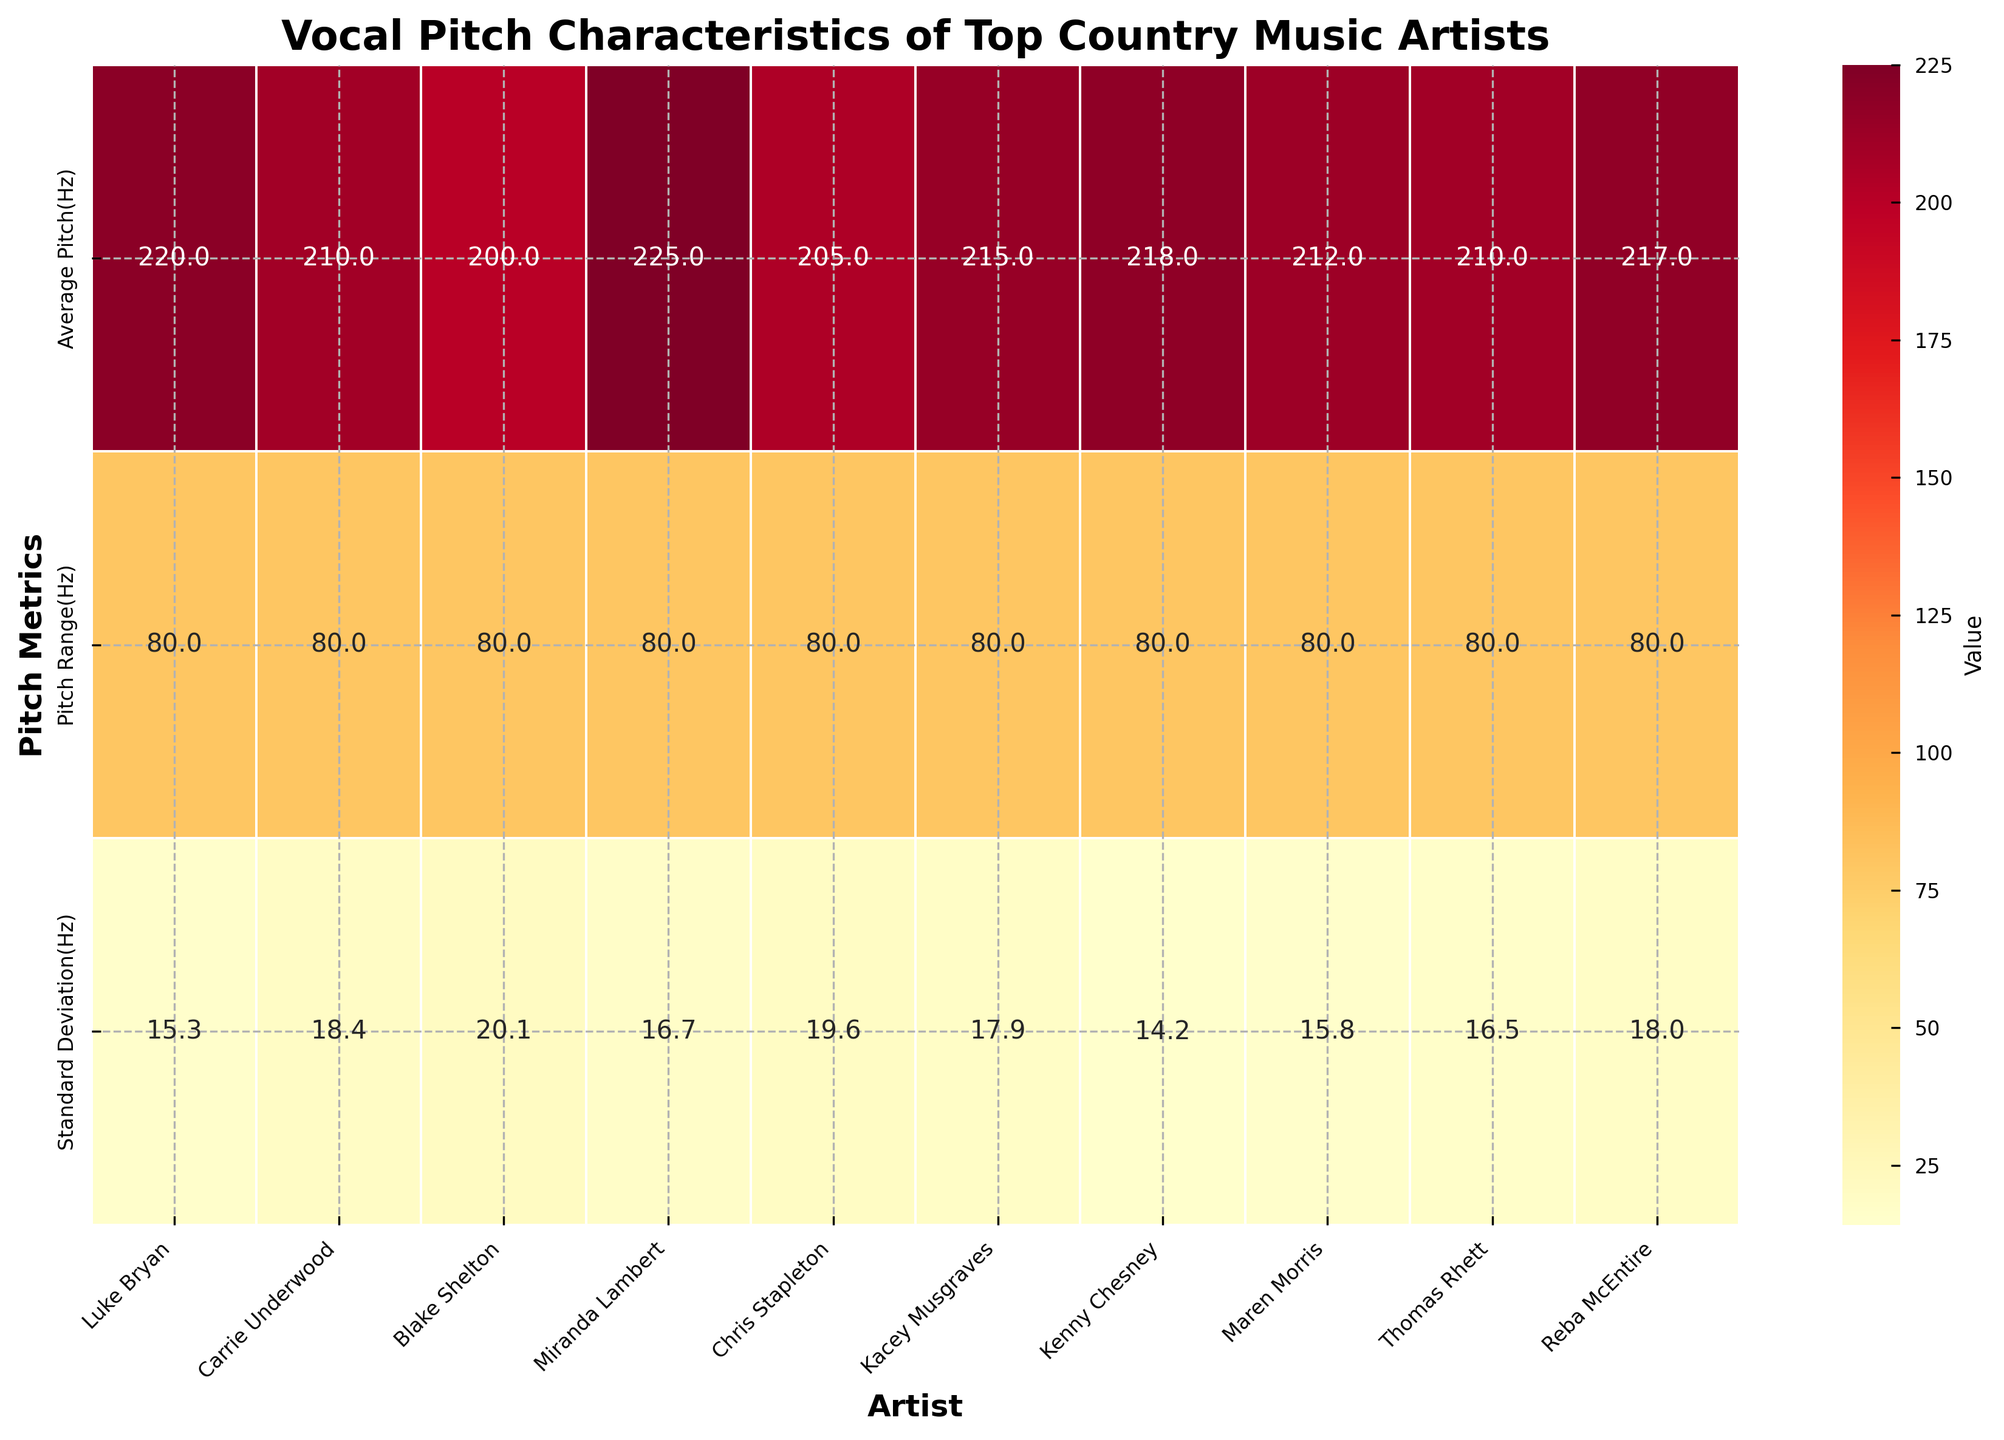Which artist has the smallest pitch range? Refer to the color intensity and numeric annotations in the heatmap to find the minimum value under the 'Pitch Range(Hz)' category.
Answer: Blake Shelton Who has the highest standard deviation in vocal pitch? Check the values and colors under the 'Standard Deviation(Hz)' category to identify the artist with the highest number.
Answer: Blake Shelton Compare the average pitch of Carrie Underwood and Luke Bryan. Who has the higher value? Compare the values under the 'Average Pitch(Hz)' category for Carrie Underwood and Luke Bryan. Carrie Underwood has 210 Hz, and Luke Bryan has 220 Hz.
Answer: Luke Bryan What is the difference in the average pitch between the artist with the highest average pitch and the one with the lowest? Identify the maximum and minimum values in the 'Average Pitch(Hz)' category and subtract the minimum from the maximum. 225 Hz (Miranda Lambert) - 200 Hz (Blake Shelton)
Answer: 25 Hz How does Maren Morris' standard deviation compare to Thomas Rhett’s? Look at the values given for standard deviation for each artist. Maren Morris has a standard deviation of 15.8 Hz while Thomas Rhett has 16.5 Hz, so you see which is greater.
Answer: Thomas Rhett's standard deviation is higher Which artist's average pitch is closest to 210 Hz? Look for the value 210 Hz in the 'Average Pitch(Hz)' category and verify which artist corresponds to it. Both Carrie Underwood and Thomas Rhett have 210 Hz listed.
Answer: Carrie Underwood and Thomas Rhett Is there an artist with both an above-average pitch range and below-average standard deviation? First, calculate the average pitch range and standard deviation of all artists. Then, find any artist whose numbers fit this criterion. The average pitch range is 83.8 Hz, and average standard deviation is 17.3 Hz. Check that Maren Morris has above the average pitch range (80 Hz) and below the average standard deviation (15.8 Hz)
Answer: Maren Morris Which artist's pitch metrics deviate the most from the average values of all artists? Calculate the average for each metric: Average Pitch (213.2 Hz), Pitch Range (83.8 Hz), and Standard Deviation (17.1 Hz). Then compare how each artist’s metrics differ the most from these averages collectively. Blake Shelton’s metrics (200 Hz, 80 Hz, 20.1 Hz) show the largest deviations.
Answer: Blake Shelton 